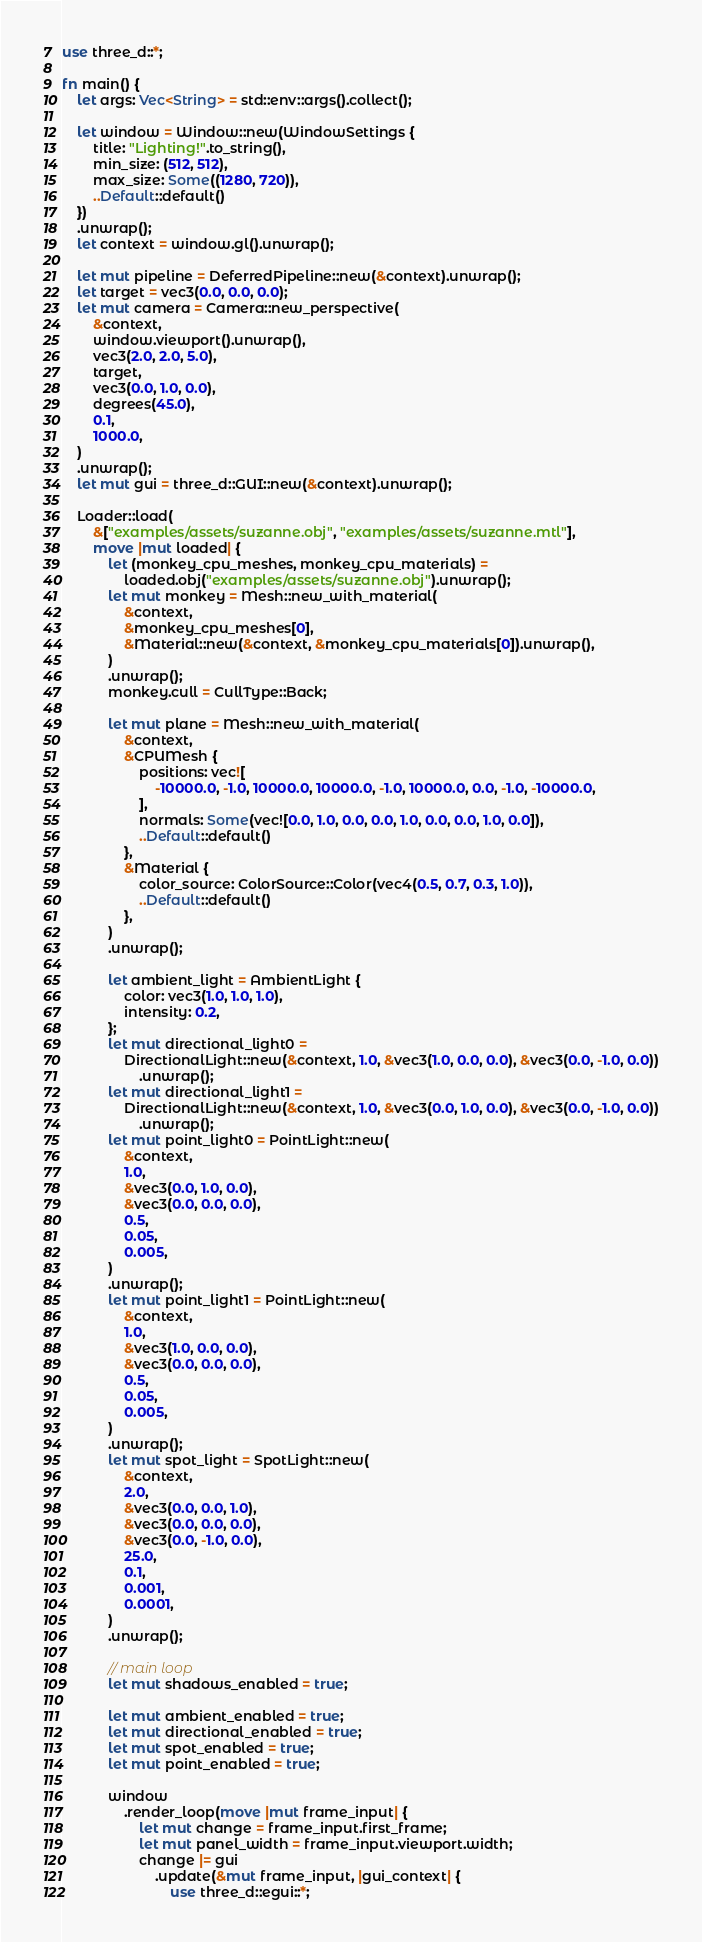Convert code to text. <code><loc_0><loc_0><loc_500><loc_500><_Rust_>use three_d::*;

fn main() {
    let args: Vec<String> = std::env::args().collect();

    let window = Window::new(WindowSettings {
        title: "Lighting!".to_string(),
        min_size: (512, 512),
        max_size: Some((1280, 720)),
        ..Default::default()
    })
    .unwrap();
    let context = window.gl().unwrap();

    let mut pipeline = DeferredPipeline::new(&context).unwrap();
    let target = vec3(0.0, 0.0, 0.0);
    let mut camera = Camera::new_perspective(
        &context,
        window.viewport().unwrap(),
        vec3(2.0, 2.0, 5.0),
        target,
        vec3(0.0, 1.0, 0.0),
        degrees(45.0),
        0.1,
        1000.0,
    )
    .unwrap();
    let mut gui = three_d::GUI::new(&context).unwrap();

    Loader::load(
        &["examples/assets/suzanne.obj", "examples/assets/suzanne.mtl"],
        move |mut loaded| {
            let (monkey_cpu_meshes, monkey_cpu_materials) =
                loaded.obj("examples/assets/suzanne.obj").unwrap();
            let mut monkey = Mesh::new_with_material(
                &context,
                &monkey_cpu_meshes[0],
                &Material::new(&context, &monkey_cpu_materials[0]).unwrap(),
            )
            .unwrap();
            monkey.cull = CullType::Back;

            let mut plane = Mesh::new_with_material(
                &context,
                &CPUMesh {
                    positions: vec![
                        -10000.0, -1.0, 10000.0, 10000.0, -1.0, 10000.0, 0.0, -1.0, -10000.0,
                    ],
                    normals: Some(vec![0.0, 1.0, 0.0, 0.0, 1.0, 0.0, 0.0, 1.0, 0.0]),
                    ..Default::default()
                },
                &Material {
                    color_source: ColorSource::Color(vec4(0.5, 0.7, 0.3, 1.0)),
                    ..Default::default()
                },
            )
            .unwrap();

            let ambient_light = AmbientLight {
                color: vec3(1.0, 1.0, 1.0),
                intensity: 0.2,
            };
            let mut directional_light0 =
                DirectionalLight::new(&context, 1.0, &vec3(1.0, 0.0, 0.0), &vec3(0.0, -1.0, 0.0))
                    .unwrap();
            let mut directional_light1 =
                DirectionalLight::new(&context, 1.0, &vec3(0.0, 1.0, 0.0), &vec3(0.0, -1.0, 0.0))
                    .unwrap();
            let mut point_light0 = PointLight::new(
                &context,
                1.0,
                &vec3(0.0, 1.0, 0.0),
                &vec3(0.0, 0.0, 0.0),
                0.5,
                0.05,
                0.005,
            )
            .unwrap();
            let mut point_light1 = PointLight::new(
                &context,
                1.0,
                &vec3(1.0, 0.0, 0.0),
                &vec3(0.0, 0.0, 0.0),
                0.5,
                0.05,
                0.005,
            )
            .unwrap();
            let mut spot_light = SpotLight::new(
                &context,
                2.0,
                &vec3(0.0, 0.0, 1.0),
                &vec3(0.0, 0.0, 0.0),
                &vec3(0.0, -1.0, 0.0),
                25.0,
                0.1,
                0.001,
                0.0001,
            )
            .unwrap();

            // main loop
            let mut shadows_enabled = true;

            let mut ambient_enabled = true;
            let mut directional_enabled = true;
            let mut spot_enabled = true;
            let mut point_enabled = true;

            window
                .render_loop(move |mut frame_input| {
                    let mut change = frame_input.first_frame;
                    let mut panel_width = frame_input.viewport.width;
                    change |= gui
                        .update(&mut frame_input, |gui_context| {
                            use three_d::egui::*;</code> 